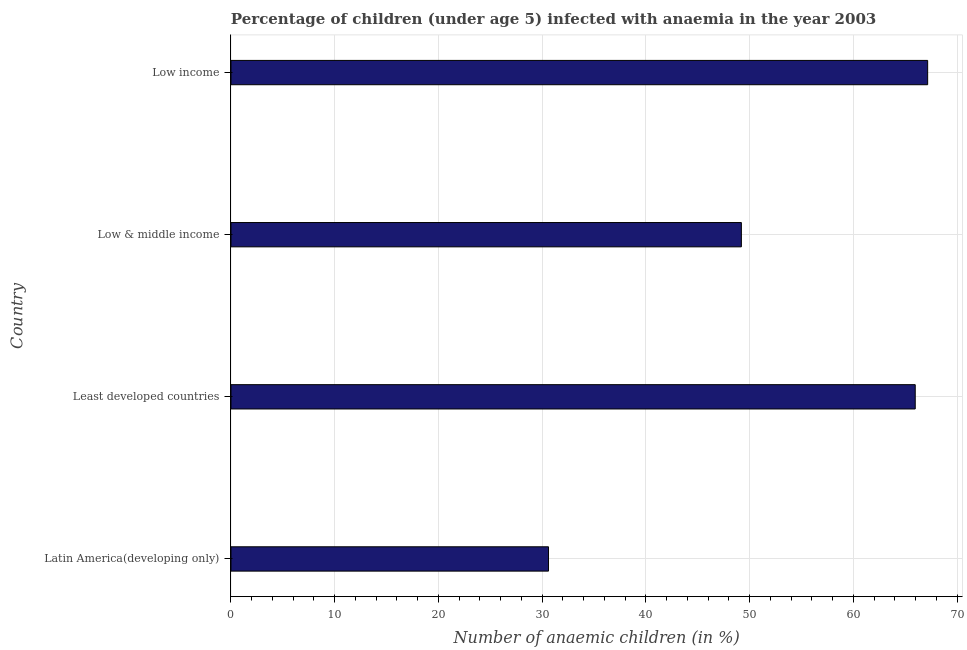Does the graph contain grids?
Your answer should be compact. Yes. What is the title of the graph?
Your answer should be very brief. Percentage of children (under age 5) infected with anaemia in the year 2003. What is the label or title of the X-axis?
Make the answer very short. Number of anaemic children (in %). What is the number of anaemic children in Latin America(developing only)?
Keep it short and to the point. 30.61. Across all countries, what is the maximum number of anaemic children?
Offer a very short reply. 67.15. Across all countries, what is the minimum number of anaemic children?
Your answer should be compact. 30.61. In which country was the number of anaemic children minimum?
Provide a succinct answer. Latin America(developing only). What is the sum of the number of anaemic children?
Your answer should be compact. 212.9. What is the difference between the number of anaemic children in Latin America(developing only) and Low income?
Offer a terse response. -36.54. What is the average number of anaemic children per country?
Your answer should be very brief. 53.23. What is the median number of anaemic children?
Your answer should be compact. 57.57. In how many countries, is the number of anaemic children greater than 20 %?
Provide a short and direct response. 4. What is the ratio of the number of anaemic children in Latin America(developing only) to that in Least developed countries?
Your response must be concise. 0.46. Is the number of anaemic children in Latin America(developing only) less than that in Low income?
Make the answer very short. Yes. What is the difference between the highest and the second highest number of anaemic children?
Your answer should be very brief. 1.2. What is the difference between the highest and the lowest number of anaemic children?
Make the answer very short. 36.54. Are the values on the major ticks of X-axis written in scientific E-notation?
Make the answer very short. No. What is the Number of anaemic children (in %) of Latin America(developing only)?
Keep it short and to the point. 30.61. What is the Number of anaemic children (in %) of Least developed countries?
Offer a terse response. 65.95. What is the Number of anaemic children (in %) in Low & middle income?
Make the answer very short. 49.2. What is the Number of anaemic children (in %) of Low income?
Give a very brief answer. 67.15. What is the difference between the Number of anaemic children (in %) in Latin America(developing only) and Least developed countries?
Give a very brief answer. -35.35. What is the difference between the Number of anaemic children (in %) in Latin America(developing only) and Low & middle income?
Your response must be concise. -18.59. What is the difference between the Number of anaemic children (in %) in Latin America(developing only) and Low income?
Provide a succinct answer. -36.54. What is the difference between the Number of anaemic children (in %) in Least developed countries and Low & middle income?
Offer a terse response. 16.76. What is the difference between the Number of anaemic children (in %) in Least developed countries and Low income?
Offer a very short reply. -1.2. What is the difference between the Number of anaemic children (in %) in Low & middle income and Low income?
Keep it short and to the point. -17.95. What is the ratio of the Number of anaemic children (in %) in Latin America(developing only) to that in Least developed countries?
Make the answer very short. 0.46. What is the ratio of the Number of anaemic children (in %) in Latin America(developing only) to that in Low & middle income?
Make the answer very short. 0.62. What is the ratio of the Number of anaemic children (in %) in Latin America(developing only) to that in Low income?
Ensure brevity in your answer.  0.46. What is the ratio of the Number of anaemic children (in %) in Least developed countries to that in Low & middle income?
Provide a short and direct response. 1.34. What is the ratio of the Number of anaemic children (in %) in Low & middle income to that in Low income?
Your answer should be compact. 0.73. 